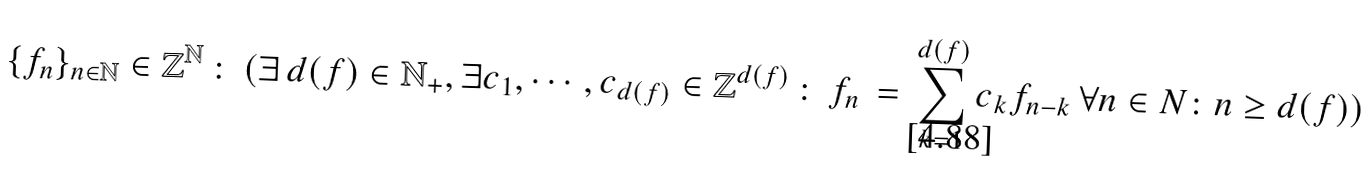Convert formula to latex. <formula><loc_0><loc_0><loc_500><loc_500>\{ f _ { n } \} _ { n \in \mathbb { N } } \in \mathbb { Z } ^ { \mathbb { N } } \, \colon \, ( \exists \, d ( f ) \in \mathbb { N } _ { + } , \exists c _ { 1 } , \cdots , c _ { d ( f ) } \in \mathbb { Z } ^ { d ( f ) } \, \colon \, f _ { n } \, = \, \sum _ { k = 1 } ^ { d ( f ) } c _ { k } f _ { n - k } \, \forall n \in N \colon n \geq d ( f ) )</formula> 